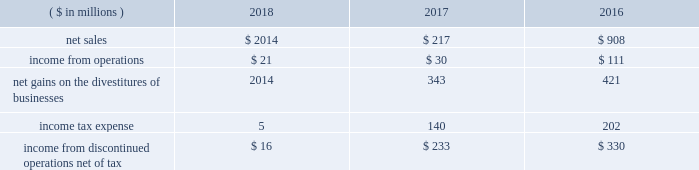2018 ppg annual report and form 10-k 59 other acquisitions in 2018 , 2017 , and 2016 , the company completed several smaller business acquisitions .
The total consideration paid for these acquisitions , net of cash acquired , debt assumed and other post closing adjustments , was $ 108 million , $ 74 million and $ 43 million , respectively .
In january 2018 , ppg acquired procoatings , a leading architectural paint and coatings wholesaler located in the netherlands .
Procoatings , established in 2001 , distributes a large portfolio of well-known professional paint brands through its network of 23 multi-brand stores .
The company employs nearly 100 people .
The results of this business since the date of acquisition have been reported within the architectural coatings americas and asia pacific business within the performance coatings reportable segment .
In january 2017 , ppg acquired certain assets of automotive refinish coatings company futian xinshi ( 201cfutian 201d ) , based in the guangdong province of china .
Futian distributes its products in china through a network of more than 200 distributors .
In january 2017 , ppg completed the acquisition of deutek s.a. , a leading romanian paint and architectural coatings manufacturer , from the emerging europe accession fund .
Deutek , established in 1993 , manufactures and markets a large portfolio of well-known professional and consumer paint brands , including oskar and danke! .
The company 2019s products are sold in more than 120 do-it-yourself stores and 3500 independent retail outlets in romania .
Divestitures glass segment in 2017 , ppg completed a multi-year strategic shift in the company's business portfolio , resulting in the exit of all glass operations which consisted of the global fiber glass business , ppg's ownership interest in two asian fiber glass joint ventures and the flat glass business .
Accordingly , the results of operations , including the gains on the divestitures , and cash flows have been recast as discontinued operations for all periods presented .
Ppg now has two reportable business segments .
The net sales and income from discontinued operations related to the former glass segment for the three years ended december 31 , 2018 , 2017 , and 2016 were as follows: .
During 2018 , ppg released $ 13 million of previously recorded accruals and contingencies established in conjunction with the divestitures of businesses within the former glass segment as a result of completed actions , new information and updated estimates .
Also during 2018 , ppg made a final payment of $ 20 million to vitro s.a.b .
De c.v related to the transfer of certain pension obligations upon the sale of the former flat glass business .
North american fiber glass business on september 1 , 2017 , ppg completed the sale of its north american fiber glass business to nippon electric glass co .
Ltd .
( 201cneg 201d ) .
Cash proceeds from the sale were $ 541 million , resulting in a pre-tax gain of $ 343 million , net of certain accruals and contingencies established in conjunction with the divestiture .
Ppg 2019s fiber glass operations included manufacturing facilities in chester , south carolina , and lexington and shelby , north carolina ; and administrative and research-and-development operations in shelby and in harmar , pennsylvania , near pittsburgh .
The business , which employed more than 1000 people and had net sales of approximately $ 350 million in 2016 , supplies the transportation , energy , infrastructure and consumer markets .
Flat glass business in october 2016 , ppg completed the sale of its flat glass manufacturing and glass coatings operations to vitro s.a.b .
De c.v .
Ppg received approximately $ 740 million in cash proceeds and recorded a pre-tax gain of $ 421 million on the sale .
Under the terms of the agreement , ppg divested its entire flat glass manufacturing and glass coatings operations , including production sites located in fresno , california ; salem , oregon ; carlisle , pennsylvania ; and wichita falls , texas ; four distribution/fabrication facilities located across canada ; and a research-and-development center located in harmar , pennsylvania .
Ppg 2019s flat glass business included approximately 1200 employees .
The business manufactures glass that is fabricated into products used primarily in commercial and residential construction .
Notes to the consolidated financial statements .
What was operating income return on sales on the discontinued glass segment in 2016? 
Computations: (111 / 908)
Answer: 0.12225. 